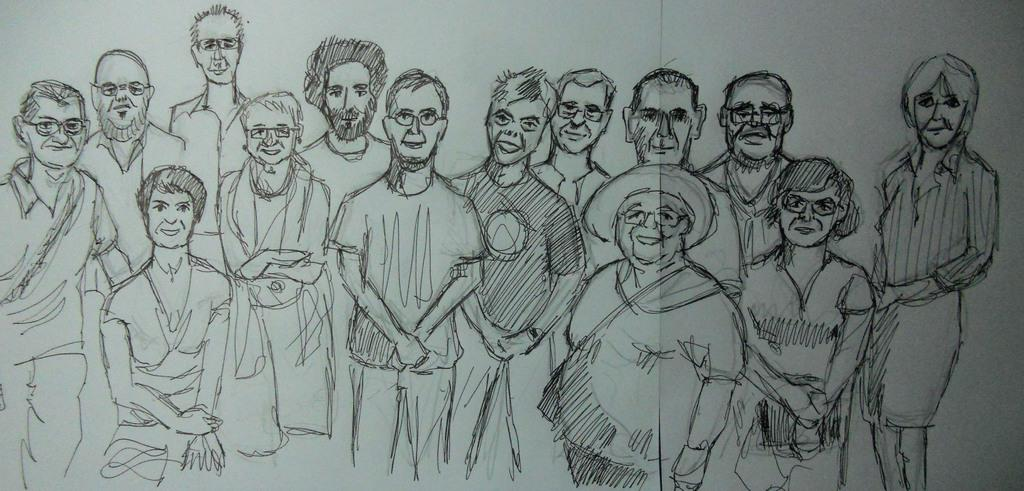What is depicted in the image? There is a sketch of people in the image. What type of breakfast is being served in the sketch? There is no breakfast depicted in the sketch, as it only features a drawing of people. 